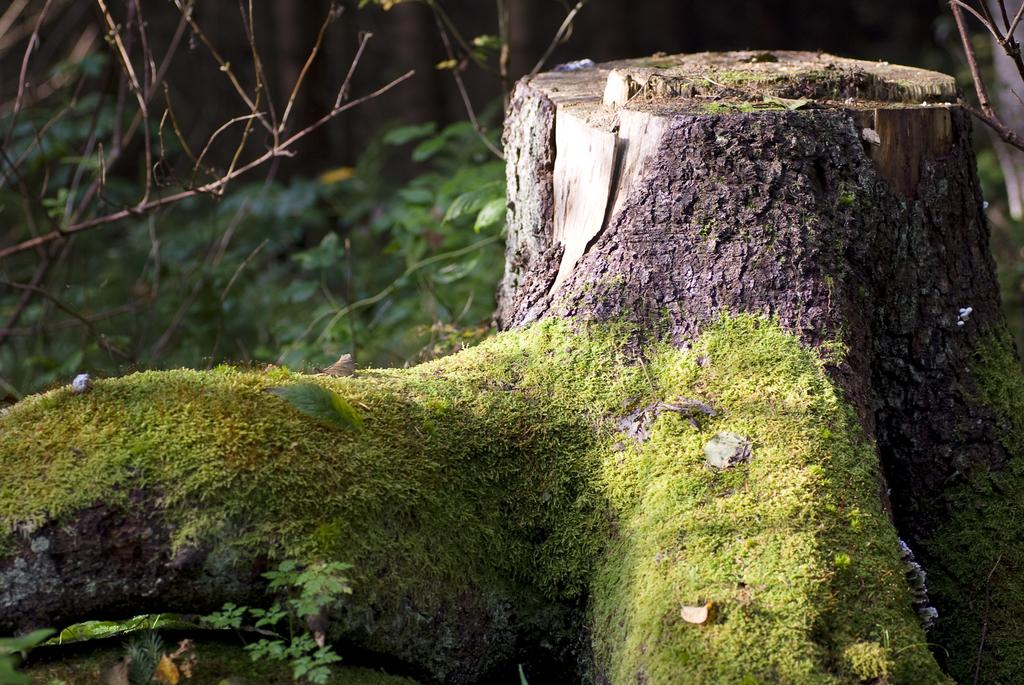What part of a tree can be seen in the image? The trunk of a tree is visible in the image. What other types of vegetation are present in the image? There are plants in the image. What type of ground cover is visible in the image? Grass is present in the image. Where is the beggar sitting on the sheet in the image? There is no beggar or sheet present in the image. How much dust can be seen on the plants in the image? There is no mention of dust in the image, and the presence or absence of dust cannot be determined from the provided facts. 